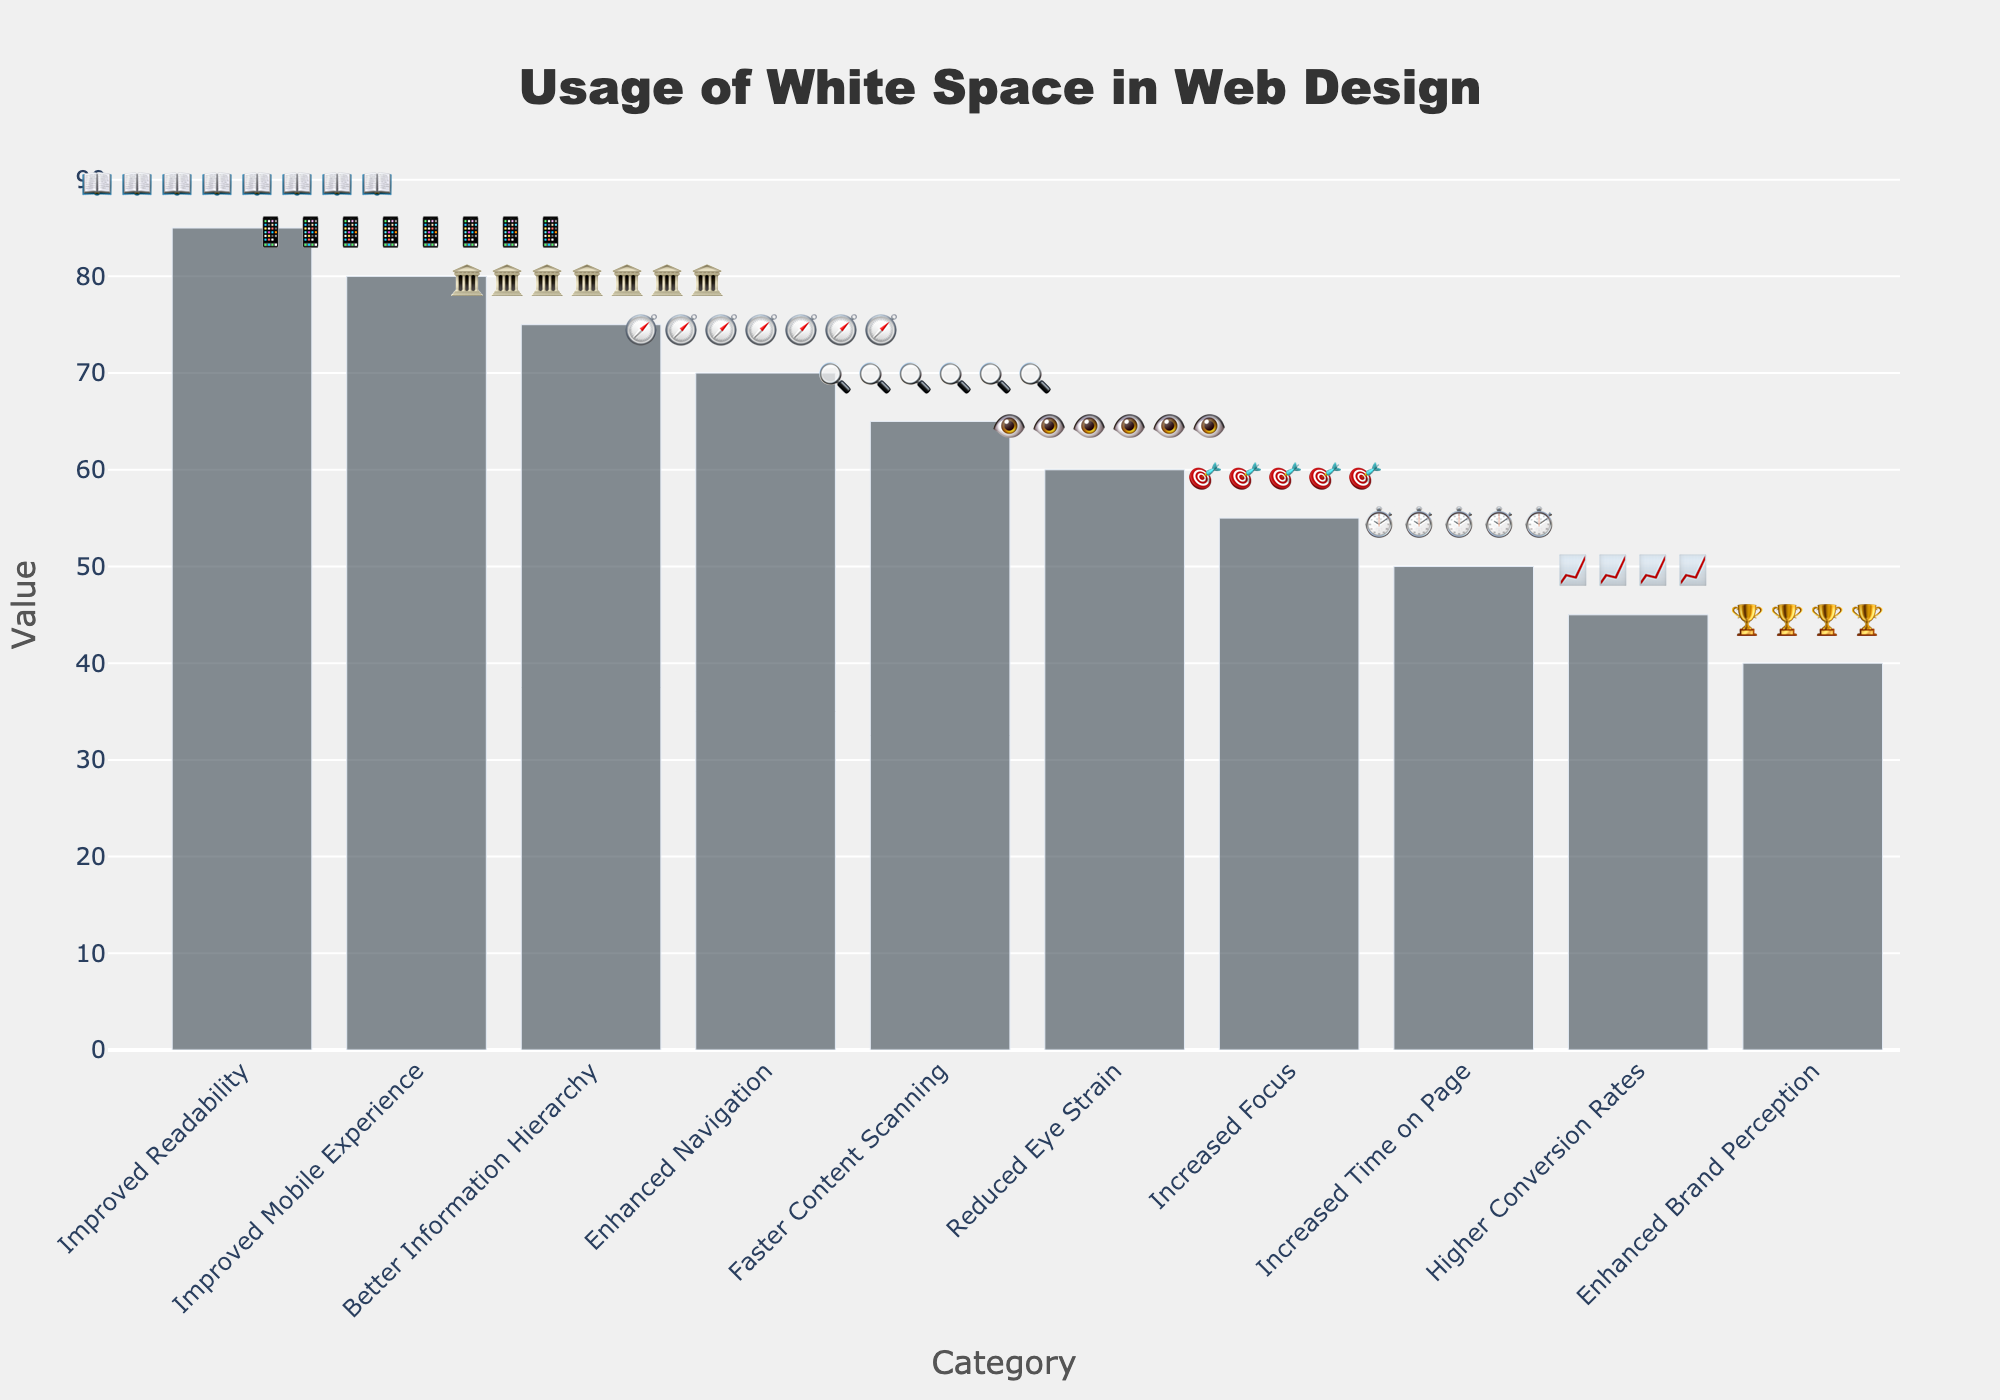What is the title of the figure? The title is prominently displayed at the top of the figure, providing a summary of what the figure is about.
Answer: Usage of White Space in Web Design What is the value associated with "Improved Readability"? The value is shown on the y-axis adjacent to the "Improved Readability" bar in the figure.
Answer: 85 Which category has the highest value? The bar with the maximum length indicates the highest value, as shown in the y-axis.
Answer: Improved Readability How many categories have a value greater than 60? By examining the y-axis and comparing each bar's length, we find the categories with values exceeding 60.
Answer: 5 What is the combined value of "Increased Time on Page" and "Higher Conversion Rates"? Sum the values of the bars corresponding to "Increased Time on Page" and "Higher Conversion Rates" categories. 50 + 45 = 95
Answer: 95 Which category has the lowest value? The shortest bar in the figure represents the lowest value, as shown in the y-axis.
Answer: Enhanced Brand Perception By how much does "Improved Mobile Experience" exceed "Faster Content Scanning"? Subtract the value of "Faster Content Scanning" from "Improved Mobile Experience": 80 - 65 = 15
Answer: 15 What distinguishes each bar visually in this Isotype Plot? Each bar is accompanied by repeated icons that represent the category, making it an Isotype Plot.
Answer: Repeated icons What is the average value of all categories? Sum all category values and divide by the number of categories: (85 + 70 + 60 + 55 + 75 + 65 + 80 + 50 + 45 + 40) / 10 = 62.5
Answer: 62.5 How many icons are used to represent "Better Information Hierarchy"? The number of icons corresponds to the value divided by 10: 75 / 10 = 7.5, rounded down to 7 full icons.
Answer: 7 